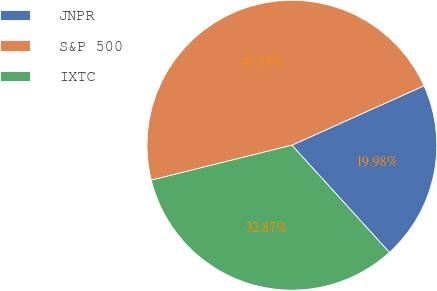Convert chart to OTSL. <chart><loc_0><loc_0><loc_500><loc_500><pie_chart><fcel>JNPR<fcel>S&P 500<fcel>IXTC<nl><fcel>19.98%<fcel>47.15%<fcel>32.87%<nl></chart> 